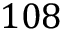<formula> <loc_0><loc_0><loc_500><loc_500>1 0 8</formula> 